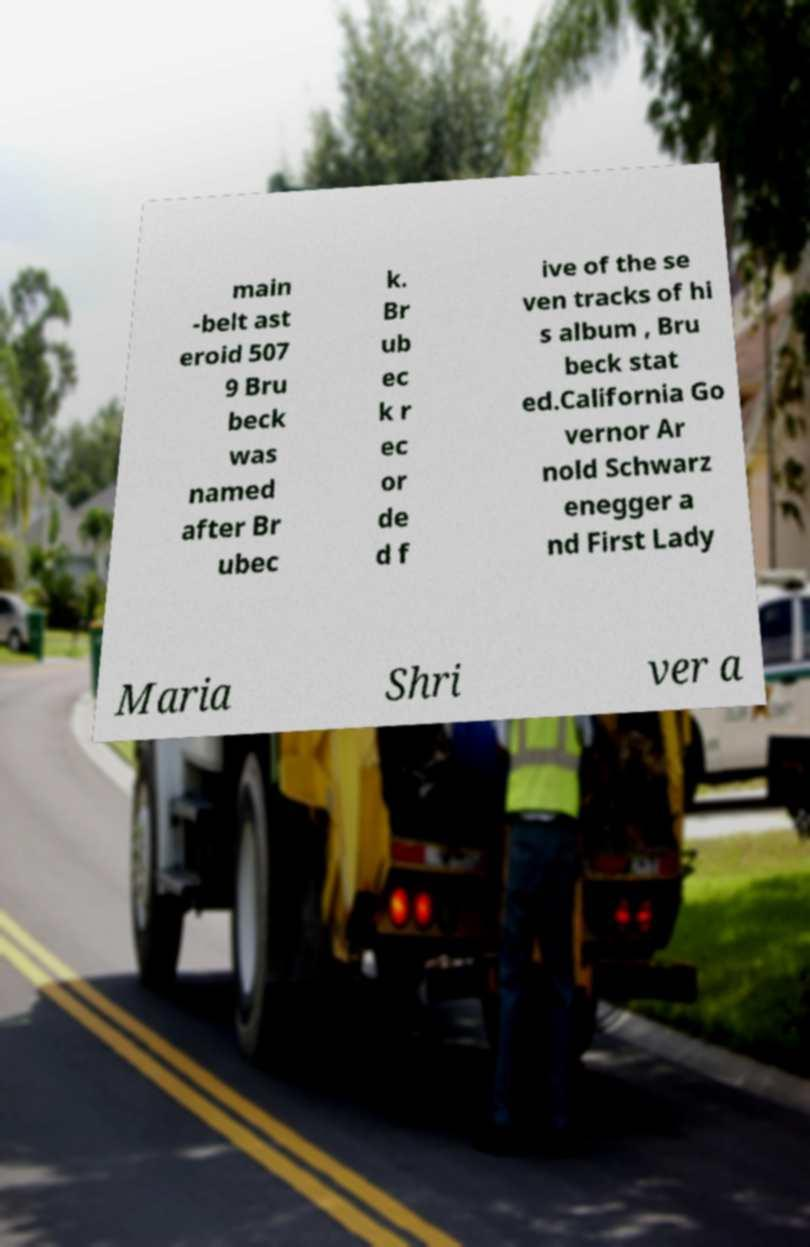Can you read and provide the text displayed in the image?This photo seems to have some interesting text. Can you extract and type it out for me? main -belt ast eroid 507 9 Bru beck was named after Br ubec k. Br ub ec k r ec or de d f ive of the se ven tracks of hi s album , Bru beck stat ed.California Go vernor Ar nold Schwarz enegger a nd First Lady Maria Shri ver a 